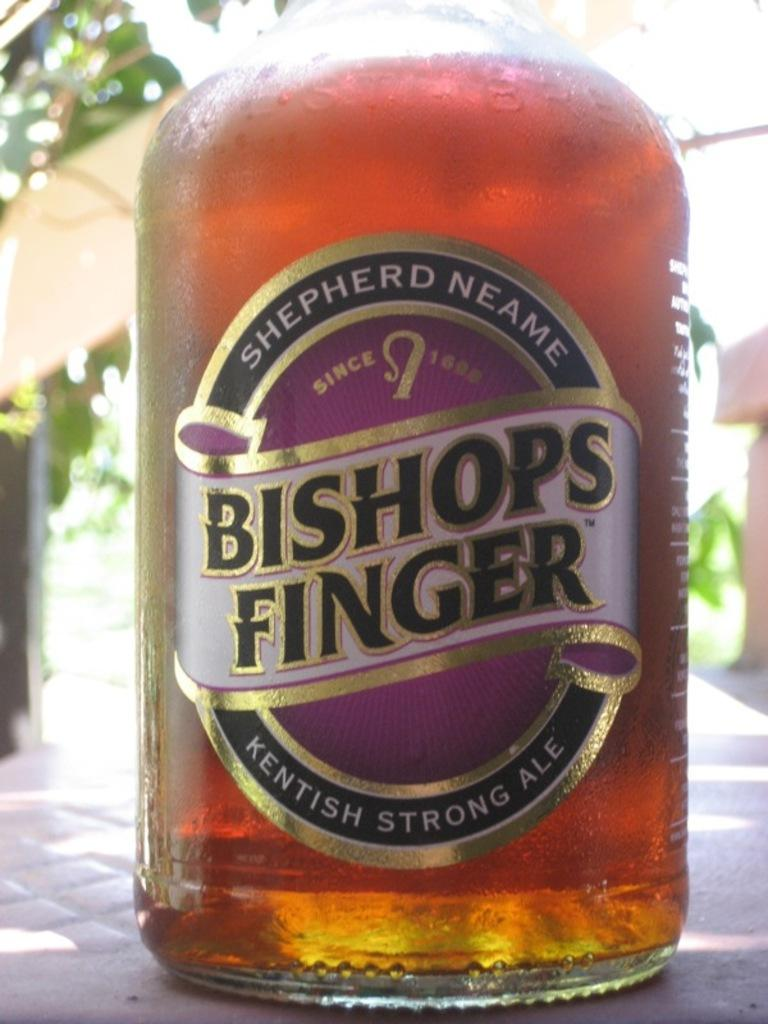<image>
Offer a succinct explanation of the picture presented. A glass of Bishops Finger Kentish Strong Ale. 